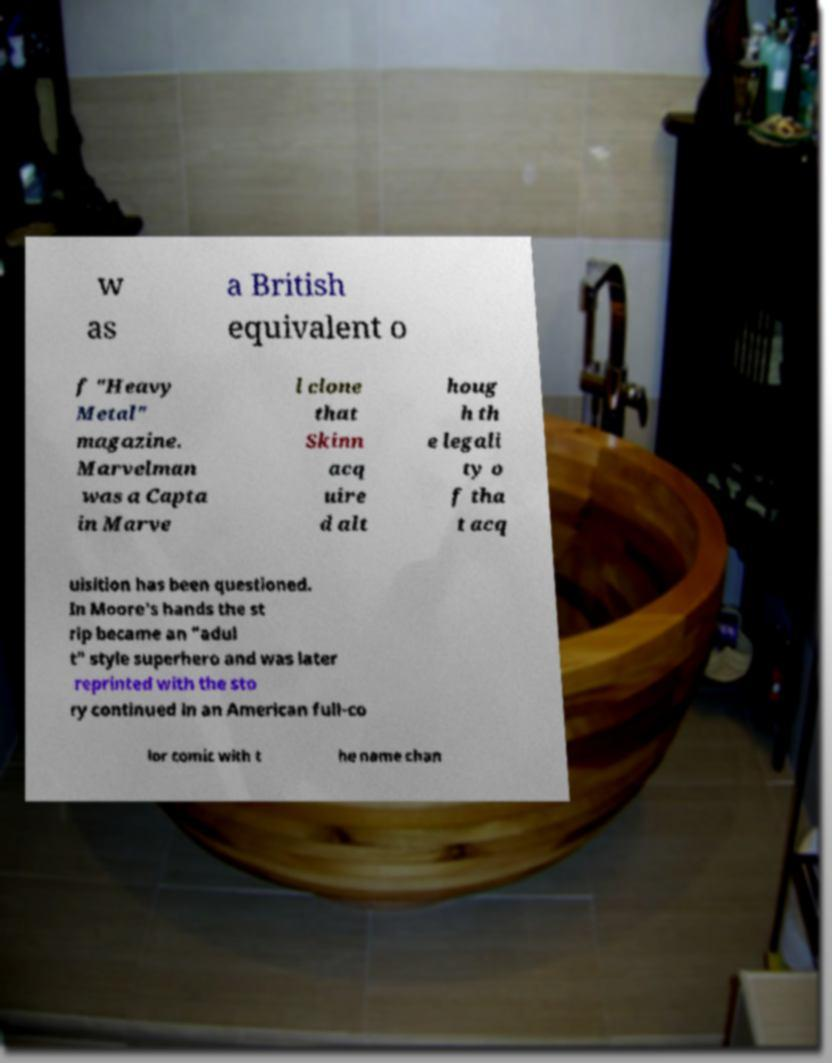I need the written content from this picture converted into text. Can you do that? w as a British equivalent o f "Heavy Metal" magazine. Marvelman was a Capta in Marve l clone that Skinn acq uire d alt houg h th e legali ty o f tha t acq uisition has been questioned. In Moore's hands the st rip became an "adul t" style superhero and was later reprinted with the sto ry continued in an American full-co lor comic with t he name chan 